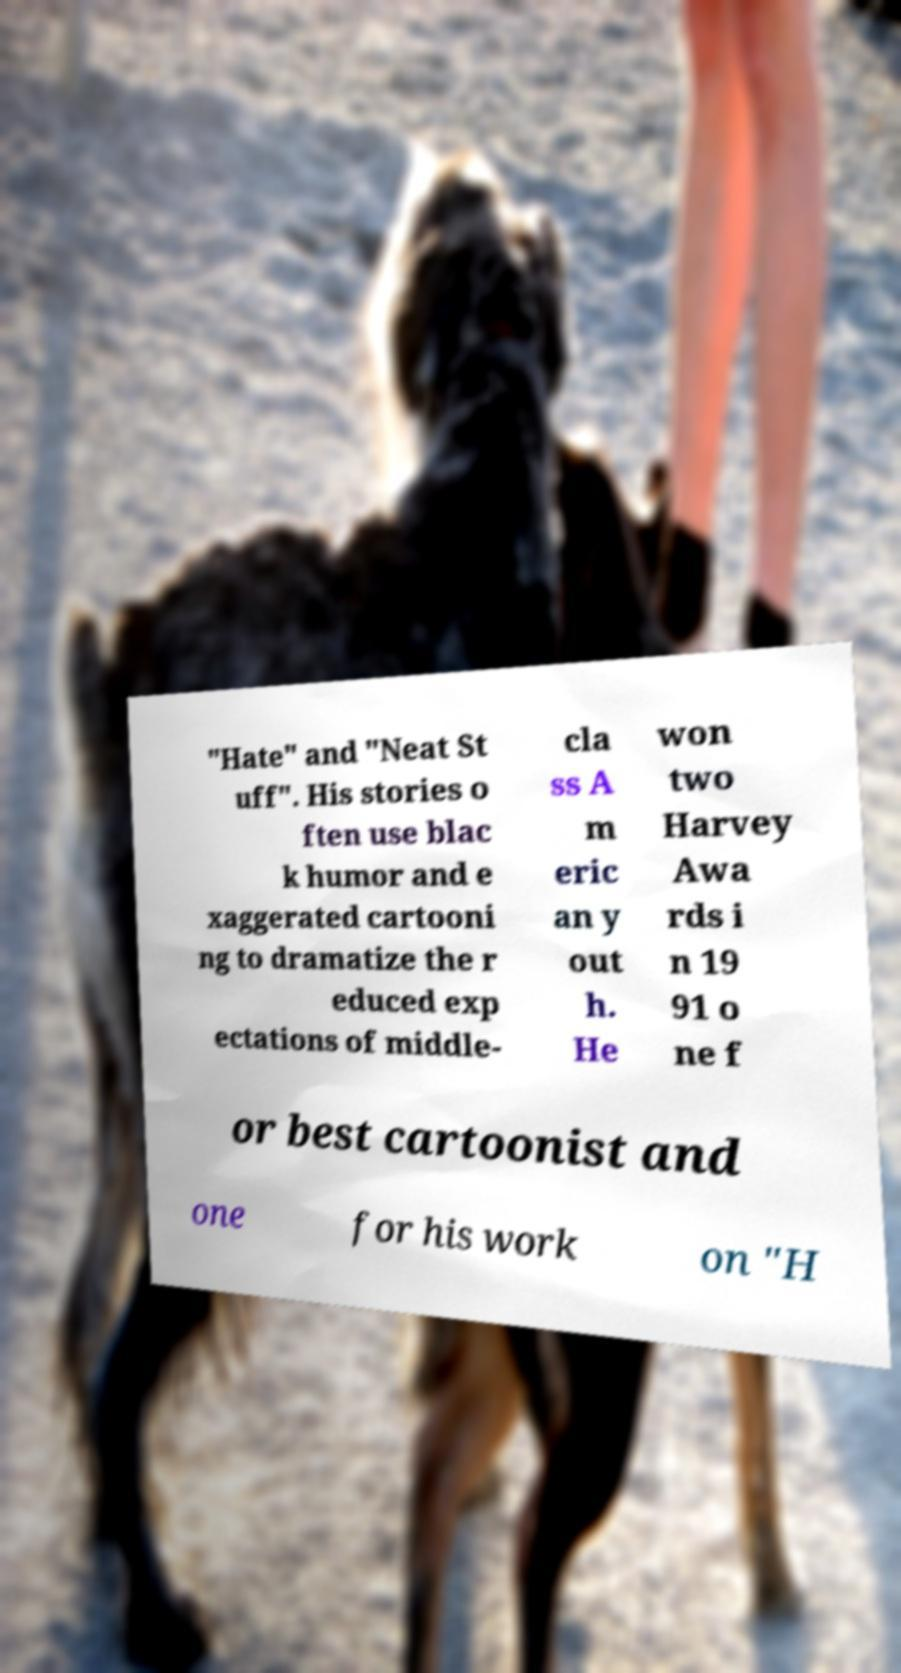Can you read and provide the text displayed in the image?This photo seems to have some interesting text. Can you extract and type it out for me? "Hate" and "Neat St uff". His stories o ften use blac k humor and e xaggerated cartooni ng to dramatize the r educed exp ectations of middle- cla ss A m eric an y out h. He won two Harvey Awa rds i n 19 91 o ne f or best cartoonist and one for his work on "H 